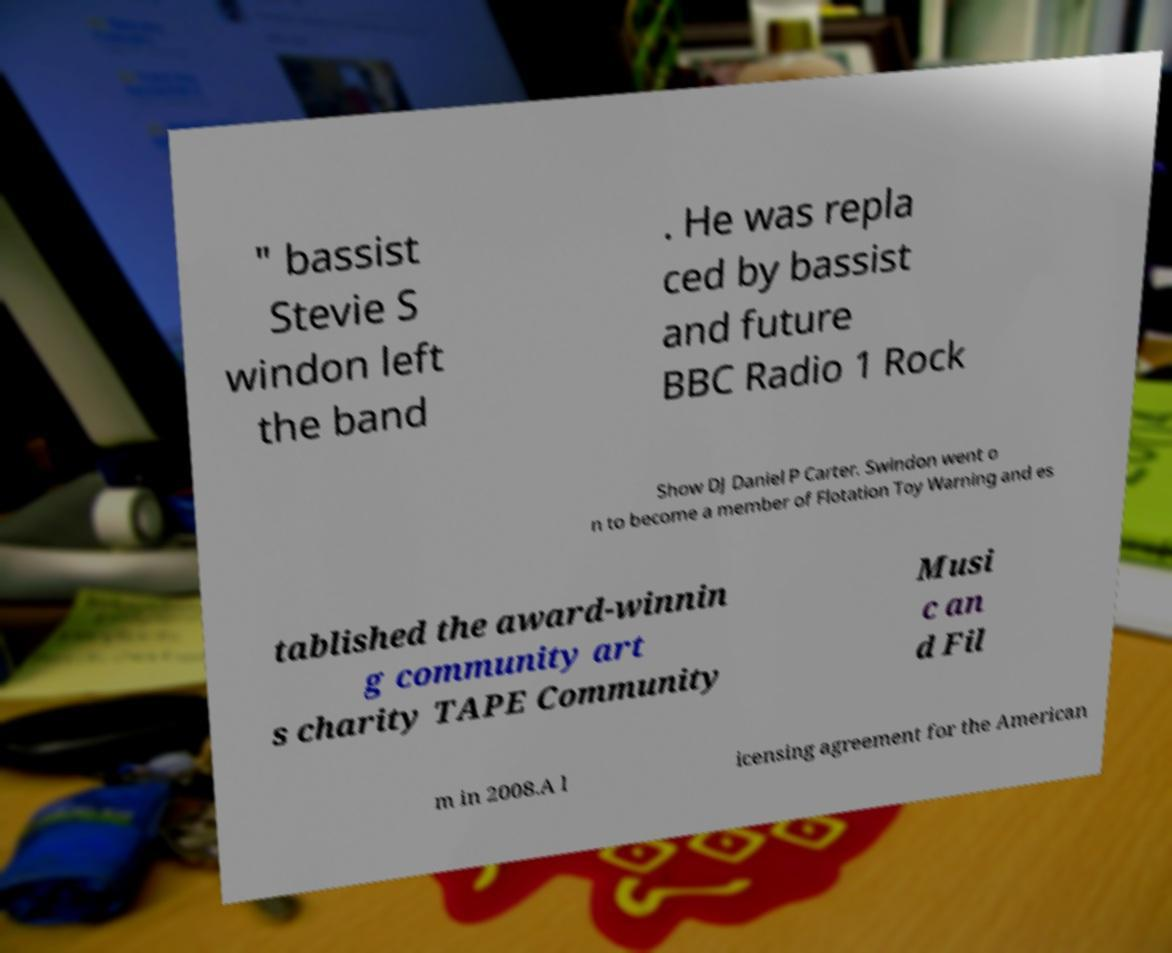For documentation purposes, I need the text within this image transcribed. Could you provide that? " bassist Stevie S windon left the band . He was repla ced by bassist and future BBC Radio 1 Rock Show DJ Daniel P Carter. Swindon went o n to become a member of Flotation Toy Warning and es tablished the award-winnin g community art s charity TAPE Community Musi c an d Fil m in 2008.A l icensing agreement for the American 